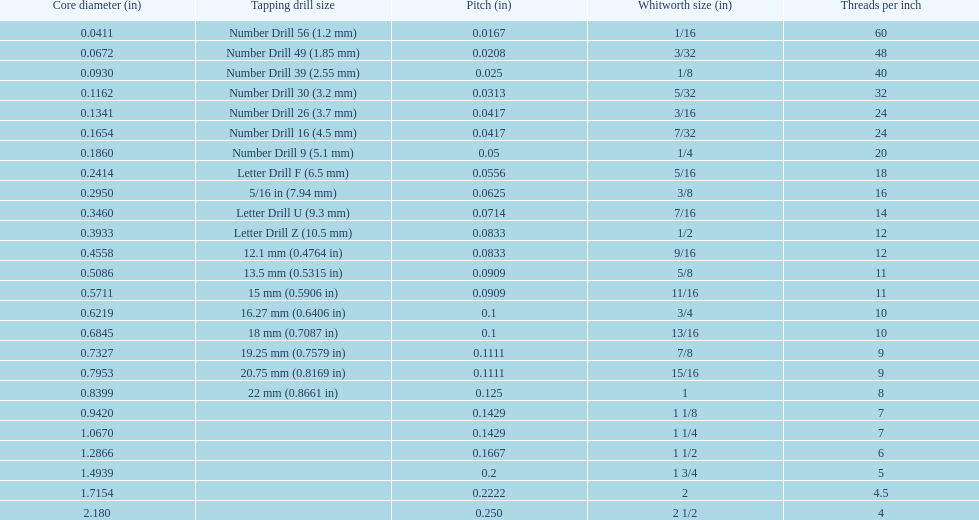What are the standard whitworth sizes in inches? 1/16, 3/32, 1/8, 5/32, 3/16, 7/32, 1/4, 5/16, 3/8, 7/16, 1/2, 9/16, 5/8, 11/16, 3/4, 13/16, 7/8, 15/16, 1, 1 1/8, 1 1/4, 1 1/2, 1 3/4, 2, 2 1/2. How many threads per inch does the 3/16 size have? 24. Which size (in inches) has the same number of threads? 7/32. 